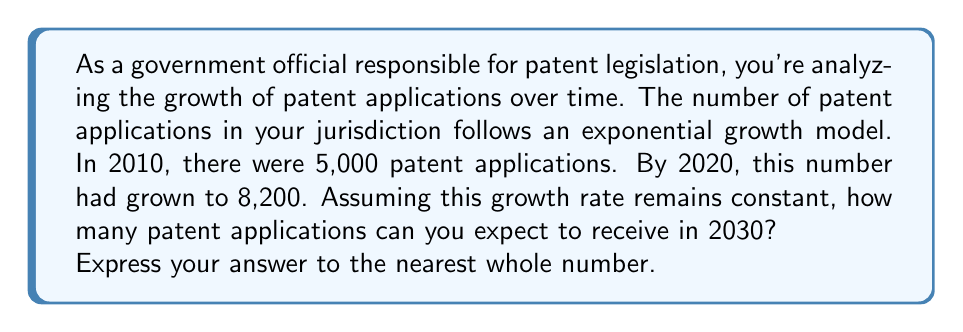Solve this math problem. Let's approach this step-by-step using the exponential growth model:

1) The general form of an exponential growth model is:
   $$ A(t) = A_0 \cdot (1 + r)^t $$
   where $A(t)$ is the amount at time $t$, $A_0$ is the initial amount, $r$ is the growth rate, and $t$ is the time period.

2) We know:
   - $A_0 = 5000$ (initial number of applications in 2010)
   - $A(10) = 8200$ (number of applications after 10 years, in 2020)
   - We need to find $A(20)$ (number of applications after 20 years, in 2030)

3) Let's find the growth rate $r$ using the given information:
   $$ 8200 = 5000 \cdot (1 + r)^{10} $$

4) Divide both sides by 5000:
   $$ 1.64 = (1 + r)^{10} $$

5) Take the 10th root of both sides:
   $$ \sqrt[10]{1.64} = 1 + r $$
   $$ 1.0507 \approx 1 + r $$
   $$ r \approx 0.0507 \text{ or } 5.07\% $$

6) Now that we have $r$, we can predict the number of applications in 2030:
   $$ A(20) = 5000 \cdot (1 + 0.0507)^{20} $$

7) Calculate:
   $$ A(20) = 5000 \cdot (1.0507)^{20} \approx 13,424.67 $$

8) Rounding to the nearest whole number: 13,425
Answer: 13,425 patent applications 